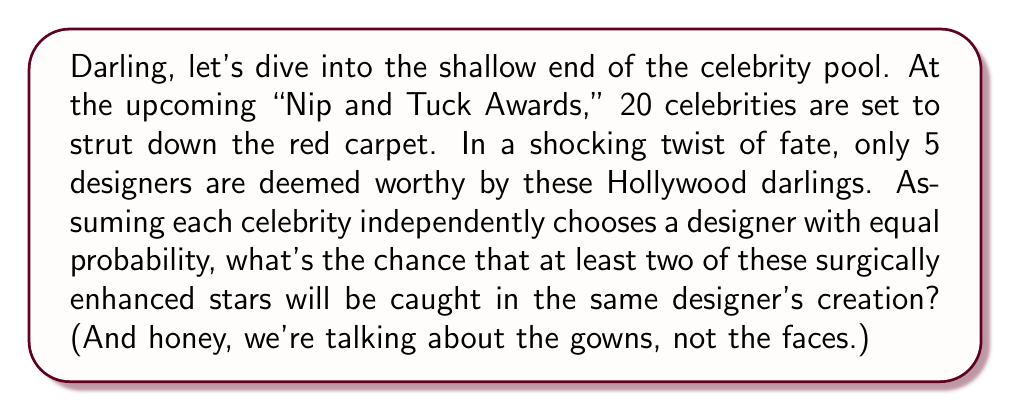Provide a solution to this math problem. Oh, the drama! Let's break this down step-by-step, shall we?

1) First, let's calculate the probability of all celebrities wearing different designers. This is easier than calculating the probability of at least two wearing the same.

2) We can use the multiplication principle here. The probability of all celebrities wearing different designers is:

   $$P(\text{all different}) = \frac{5}{5} \cdot \frac{4}{5} \cdot \frac{3}{5} \cdot \frac{2}{5} \cdot \frac{1}{5} \cdot \left(\frac{0}{5}\right)^{15}$$

3) This can be written more succinctly using the falling factorial notation:

   $$P(\text{all different}) = \frac{5_{(5)}}{5^{20}}$$

   Where $5_{(5)} = 5 \cdot 4 \cdot 3 \cdot 2 \cdot 1 = 120$

4) Now, let's calculate:

   $$P(\text{all different}) = \frac{120}{5^{20}} \approx 7.6294 \times 10^{-13}$$

5) The probability of at least two celebrities wearing the same designer is the complement of this probability:

   $$P(\text{at least two same}) = 1 - P(\text{all different})$$

6) Therefore:

   $$P(\text{at least two same}) = 1 - 7.6294 \times 10^{-13} \approx 0.9999999999992371$$

So, darling, it's practically a certainty. But then again, in Hollywood, what isn't?
Answer: The probability is approximately 0.9999999999992371 or 99.99999999992371%. 